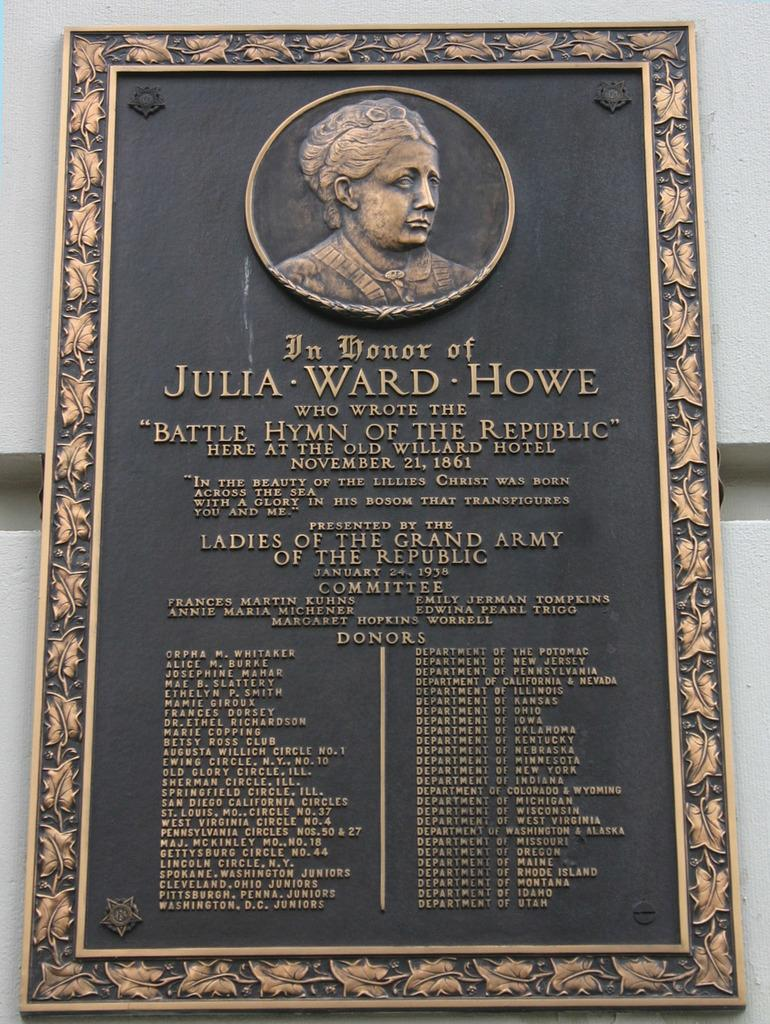<image>
Create a compact narrative representing the image presented. A dedication sign with a woman's picture on it and Julia Ward Howe on it. 